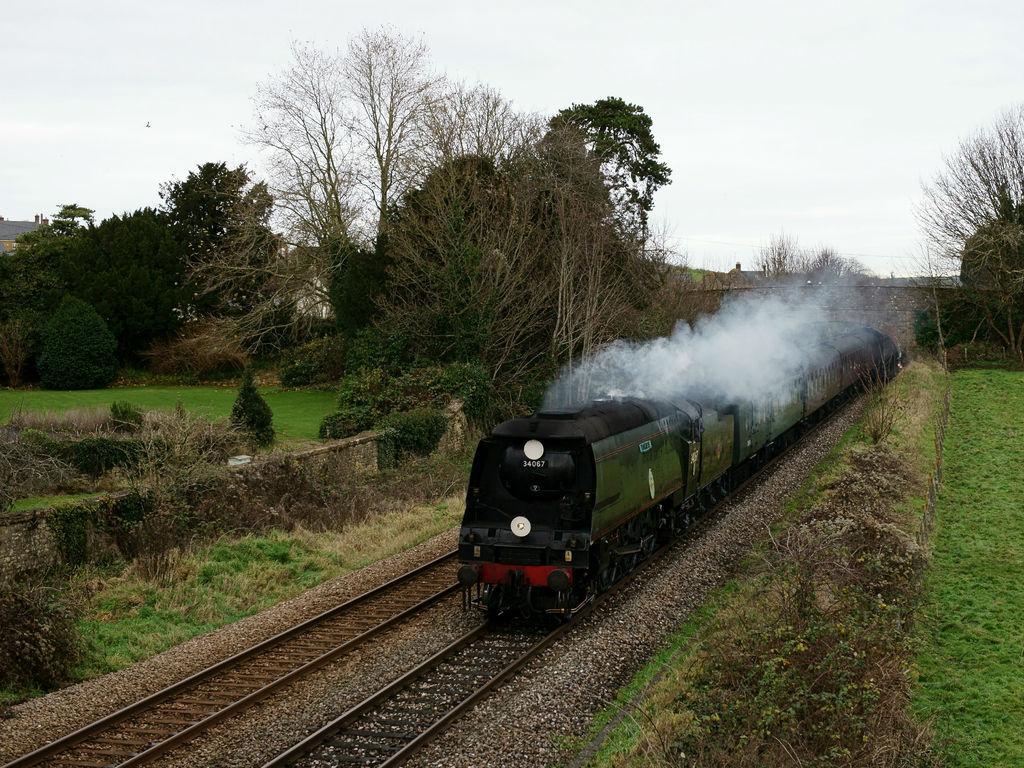Describe this image in one or two sentences. In this image I can see the ground, some grass on the ground, few plants, two railway tracks on the ground and a train which is green and black in color on the track. I can see smoke coming from the train and few trees. In the background I can see the sky. 